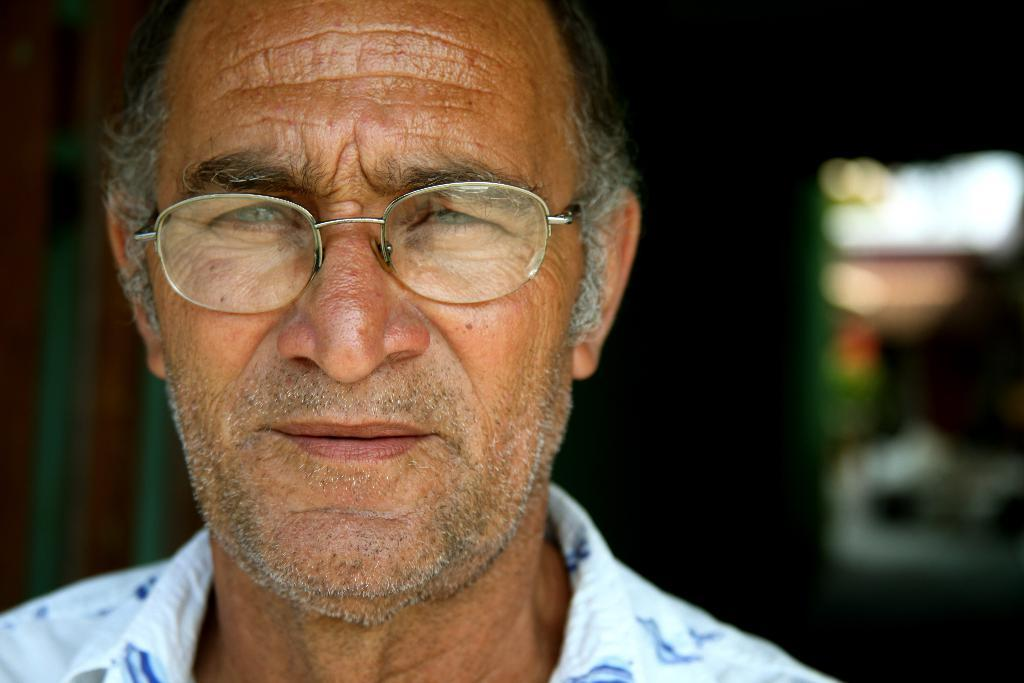What is present in the image? There is a man in the image. Can you describe the man's appearance? The man is wearing spectacles. What can be observed about the background of the image? The background of the image is blurry. What type of fan can be seen in the image? There is no fan present in the image. What list is the man holding in the image? There is no list present in the image. 